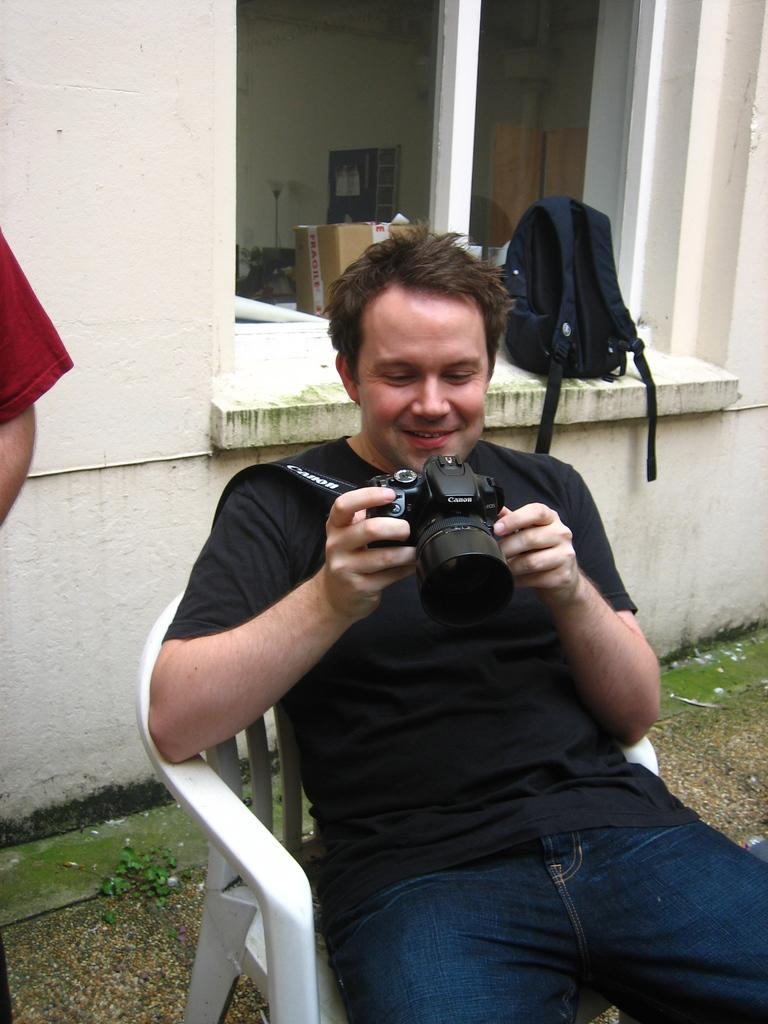Who is the main subject in the image? There is a man in the image. What is the man doing in the image? The man is sitting on a chair and holding a camera. Is there anything else visible behind the man? Yes, there is a bag behind the man. What type of crown is the man wearing in the image? There is no crown present in the image; the man is holding a camera. 